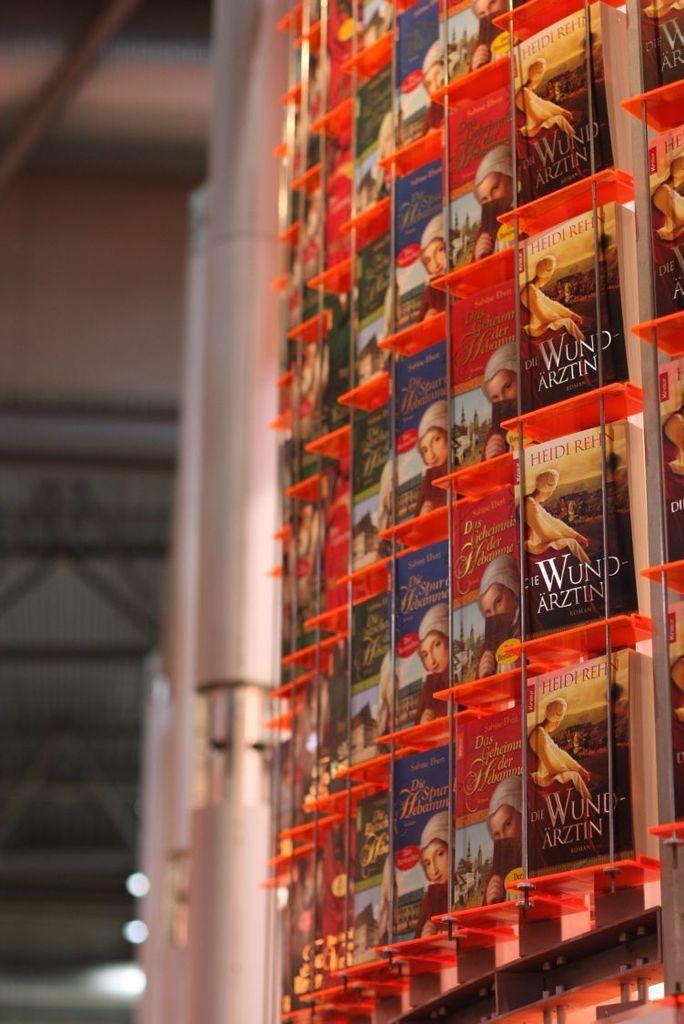What is the main subject of the image? The main subject of the image is many books. How are the books arranged in the image? The books are kept in a rack. What can be seen above the books in the image? There is a roof visible in the image. What else is present near the books in the image? There are rods beside the books. What type of substance is being used to clean the church in the image? There is no church or cleaning substance present in the image; it features books in a rack with a roof and rods. 